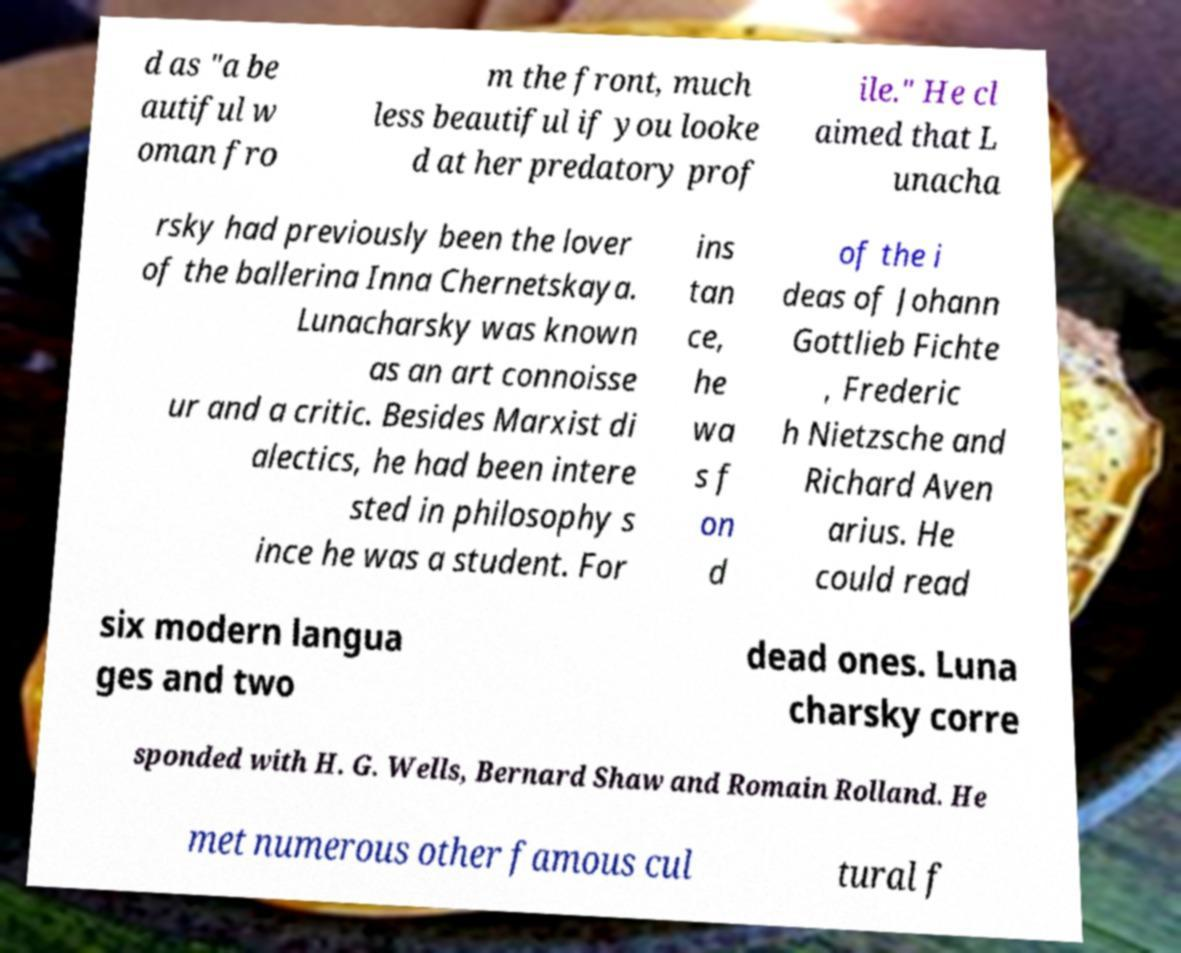There's text embedded in this image that I need extracted. Can you transcribe it verbatim? d as "a be autiful w oman fro m the front, much less beautiful if you looke d at her predatory prof ile." He cl aimed that L unacha rsky had previously been the lover of the ballerina Inna Chernetskaya. Lunacharsky was known as an art connoisse ur and a critic. Besides Marxist di alectics, he had been intere sted in philosophy s ince he was a student. For ins tan ce, he wa s f on d of the i deas of Johann Gottlieb Fichte , Frederic h Nietzsche and Richard Aven arius. He could read six modern langua ges and two dead ones. Luna charsky corre sponded with H. G. Wells, Bernard Shaw and Romain Rolland. He met numerous other famous cul tural f 